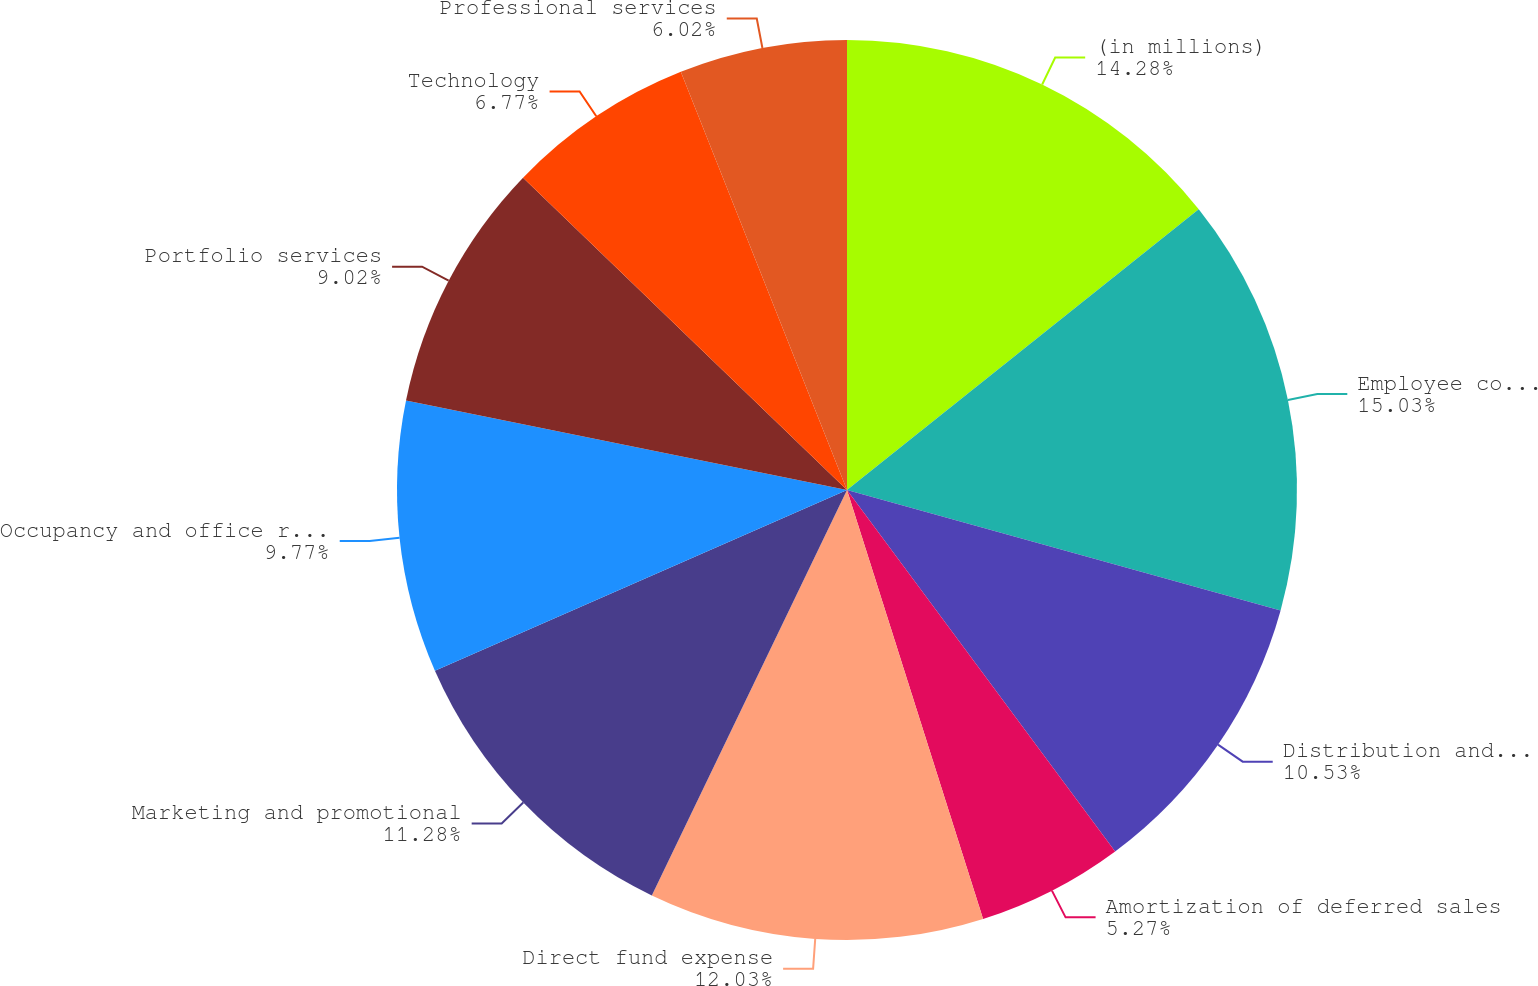Convert chart. <chart><loc_0><loc_0><loc_500><loc_500><pie_chart><fcel>(in millions)<fcel>Employee compensation and<fcel>Distribution and servicing<fcel>Amortization of deferred sales<fcel>Direct fund expense<fcel>Marketing and promotional<fcel>Occupancy and office related<fcel>Portfolio services<fcel>Technology<fcel>Professional services<nl><fcel>14.28%<fcel>15.03%<fcel>10.53%<fcel>5.27%<fcel>12.03%<fcel>11.28%<fcel>9.77%<fcel>9.02%<fcel>6.77%<fcel>6.02%<nl></chart> 